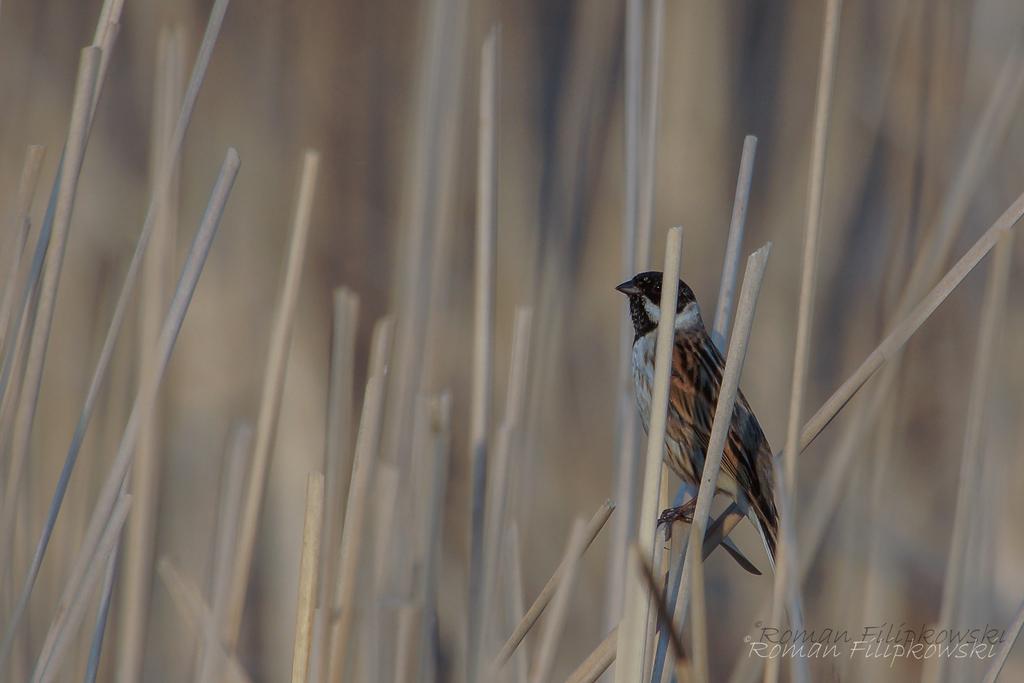Describe this image in one or two sentences. There is one bird present on a wooden stick is on the right side of this image, and there are some other wooden sticks in the background. There is a watermark at the bottom right corner of this image. 